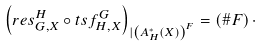<formula> <loc_0><loc_0><loc_500><loc_500>\left ( r e s _ { G , X } ^ { H } \circ t s f _ { H , X } ^ { G } \right ) _ { | \left ( A _ { H } ^ { * } \left ( X \right ) \right ) ^ { F } } = \left ( \# F \right ) \cdot</formula> 